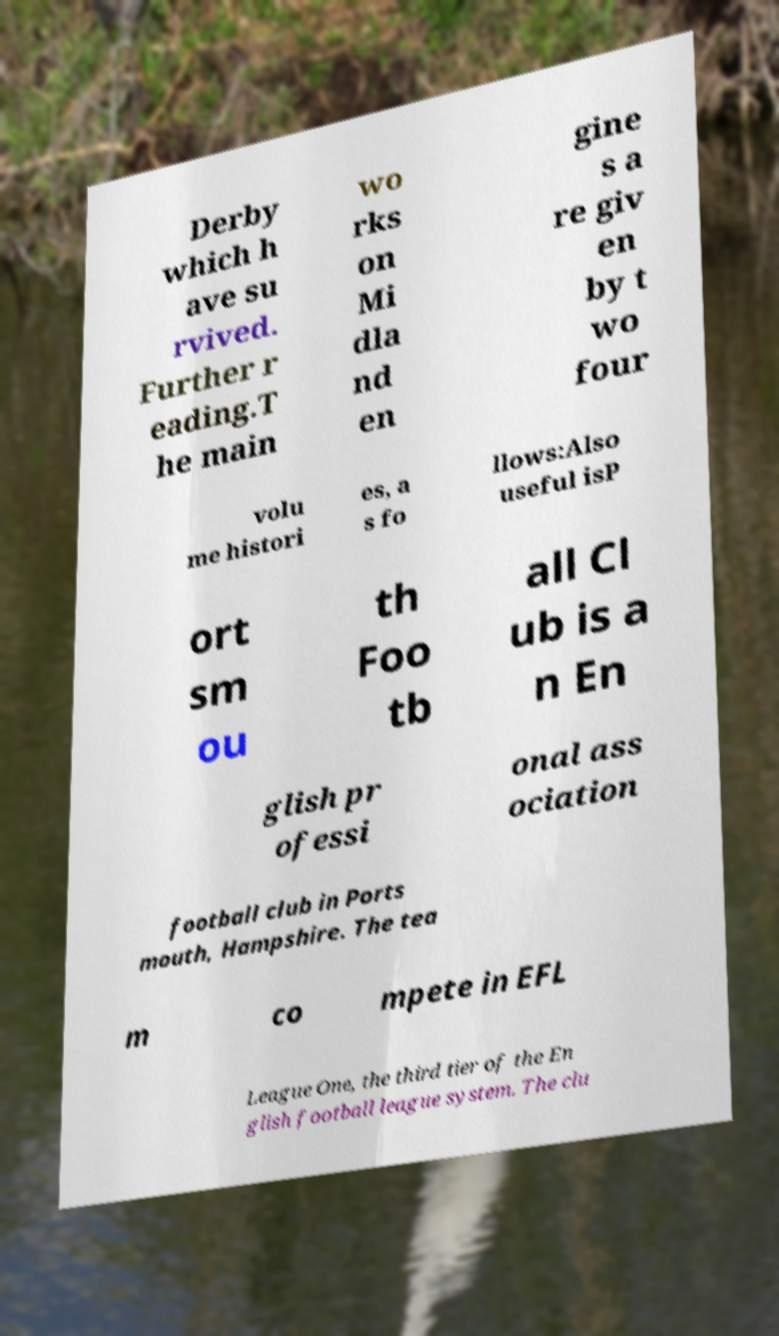What messages or text are displayed in this image? I need them in a readable, typed format. Derby which h ave su rvived. Further r eading.T he main wo rks on Mi dla nd en gine s a re giv en by t wo four volu me histori es, a s fo llows:Also useful isP ort sm ou th Foo tb all Cl ub is a n En glish pr ofessi onal ass ociation football club in Ports mouth, Hampshire. The tea m co mpete in EFL League One, the third tier of the En glish football league system. The clu 